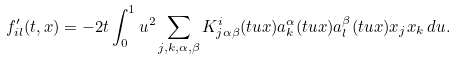<formula> <loc_0><loc_0><loc_500><loc_500>f _ { i l } ^ { \prime } ( t , x ) = - 2 t \int _ { 0 } ^ { 1 } u ^ { 2 } \sum _ { j , k , \alpha , \beta } K ^ { i } _ { j \alpha \beta } ( t u x ) a ^ { \alpha } _ { k } ( t u x ) a ^ { \beta } _ { l } ( t u x ) x _ { j } x _ { k } \, d u .</formula> 